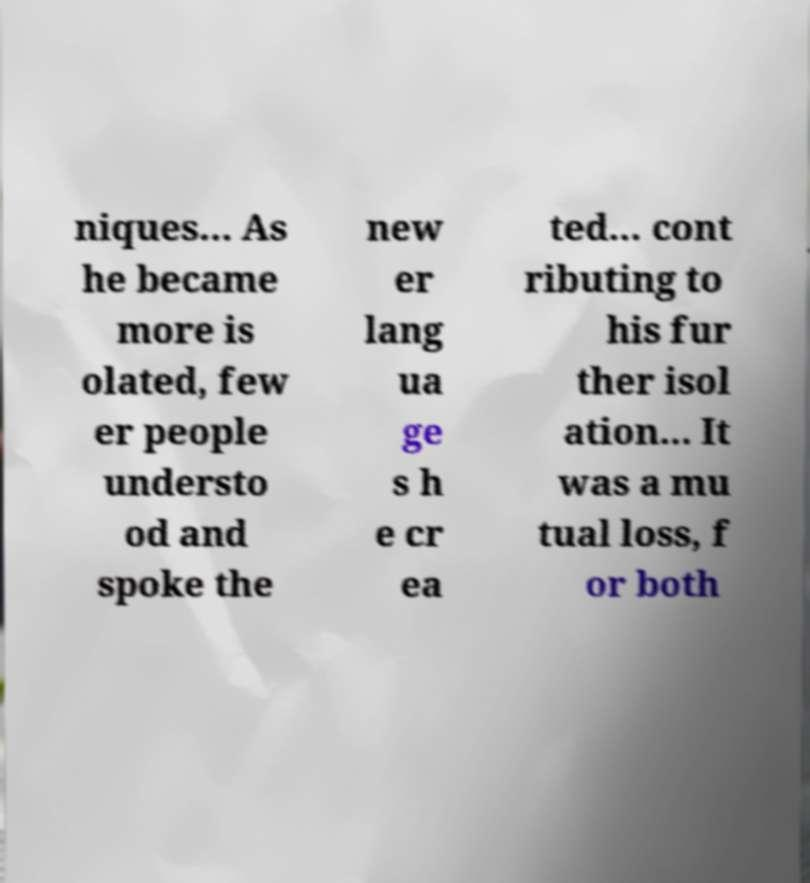Could you assist in decoding the text presented in this image and type it out clearly? niques… As he became more is olated, few er people understo od and spoke the new er lang ua ge s h e cr ea ted… cont ributing to his fur ther isol ation... It was a mu tual loss, f or both 